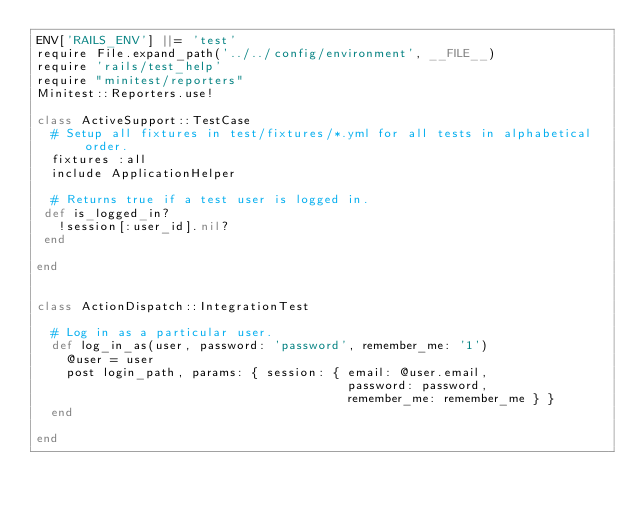<code> <loc_0><loc_0><loc_500><loc_500><_Ruby_>ENV['RAILS_ENV'] ||= 'test'
require File.expand_path('../../config/environment', __FILE__)
require 'rails/test_help'
require "minitest/reporters"
Minitest::Reporters.use!

class ActiveSupport::TestCase
  # Setup all fixtures in test/fixtures/*.yml for all tests in alphabetical order.
  fixtures :all
  include ApplicationHelper

  # Returns true if a test user is logged in.
 def is_logged_in?
   !session[:user_id].nil?
 end

end  


class ActionDispatch::IntegrationTest

  # Log in as a particular user.
  def log_in_as(user, password: 'password', remember_me: '1')
    @user = user
    post login_path, params: { session: { email: @user.email,
                                          password: password,
                                          remember_me: remember_me } }
  end

end
</code> 